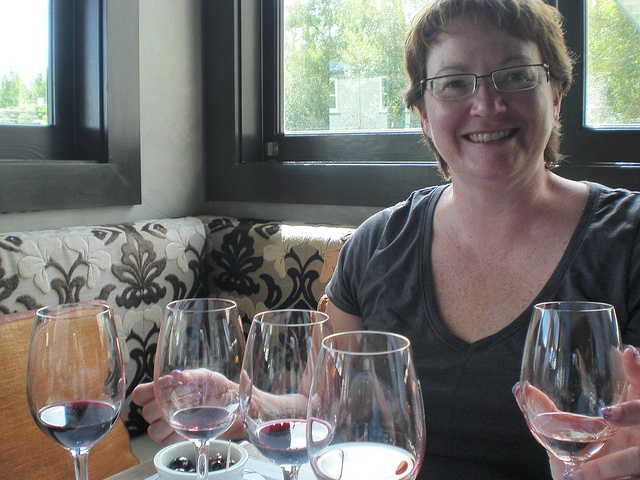Describe the objects in this image and their specific colors. I can see people in white, black, gray, and darkgray tones, couch in white, darkgray, gray, black, and lightgray tones, wine glass in white, gray, and darkgray tones, wine glass in white, gray, black, and darkgray tones, and wine glass in white, gray, tan, and darkgray tones in this image. 